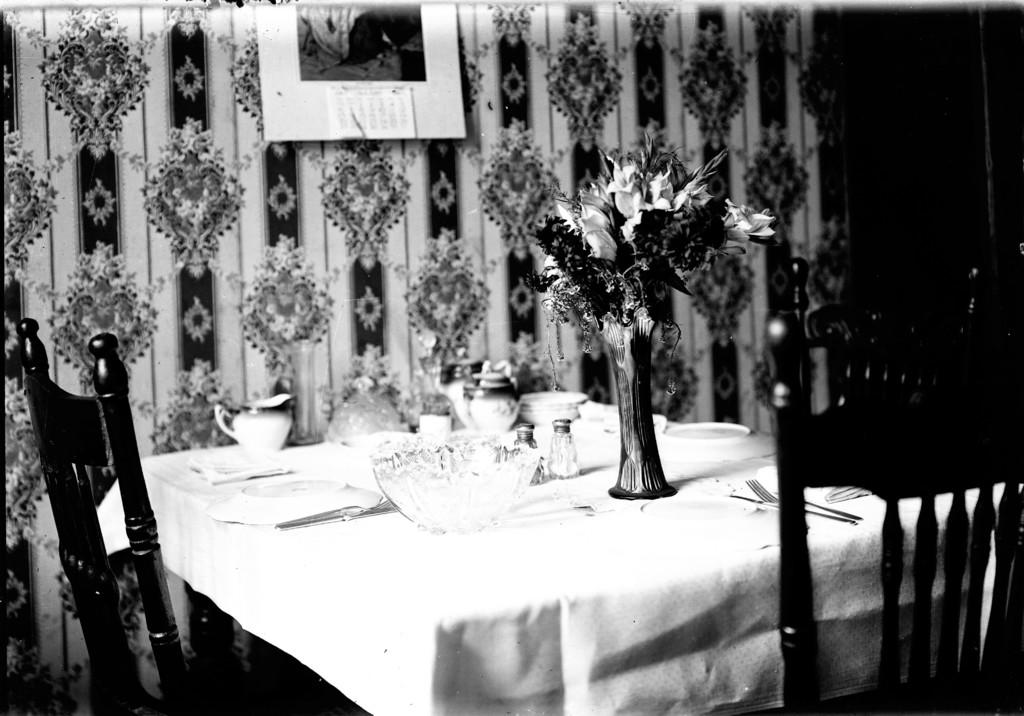What type of furniture is present in the image? There are chairs and a table in the image. What items can be seen on the table? There are cups, plates, spoons, a bowl, and a flower on the table. Is there any decoration visible in the image? Yes, there is a poster on the wall. Can you see a flock of birds on the stage in the image? There is no stage or flock of birds present in the image. 